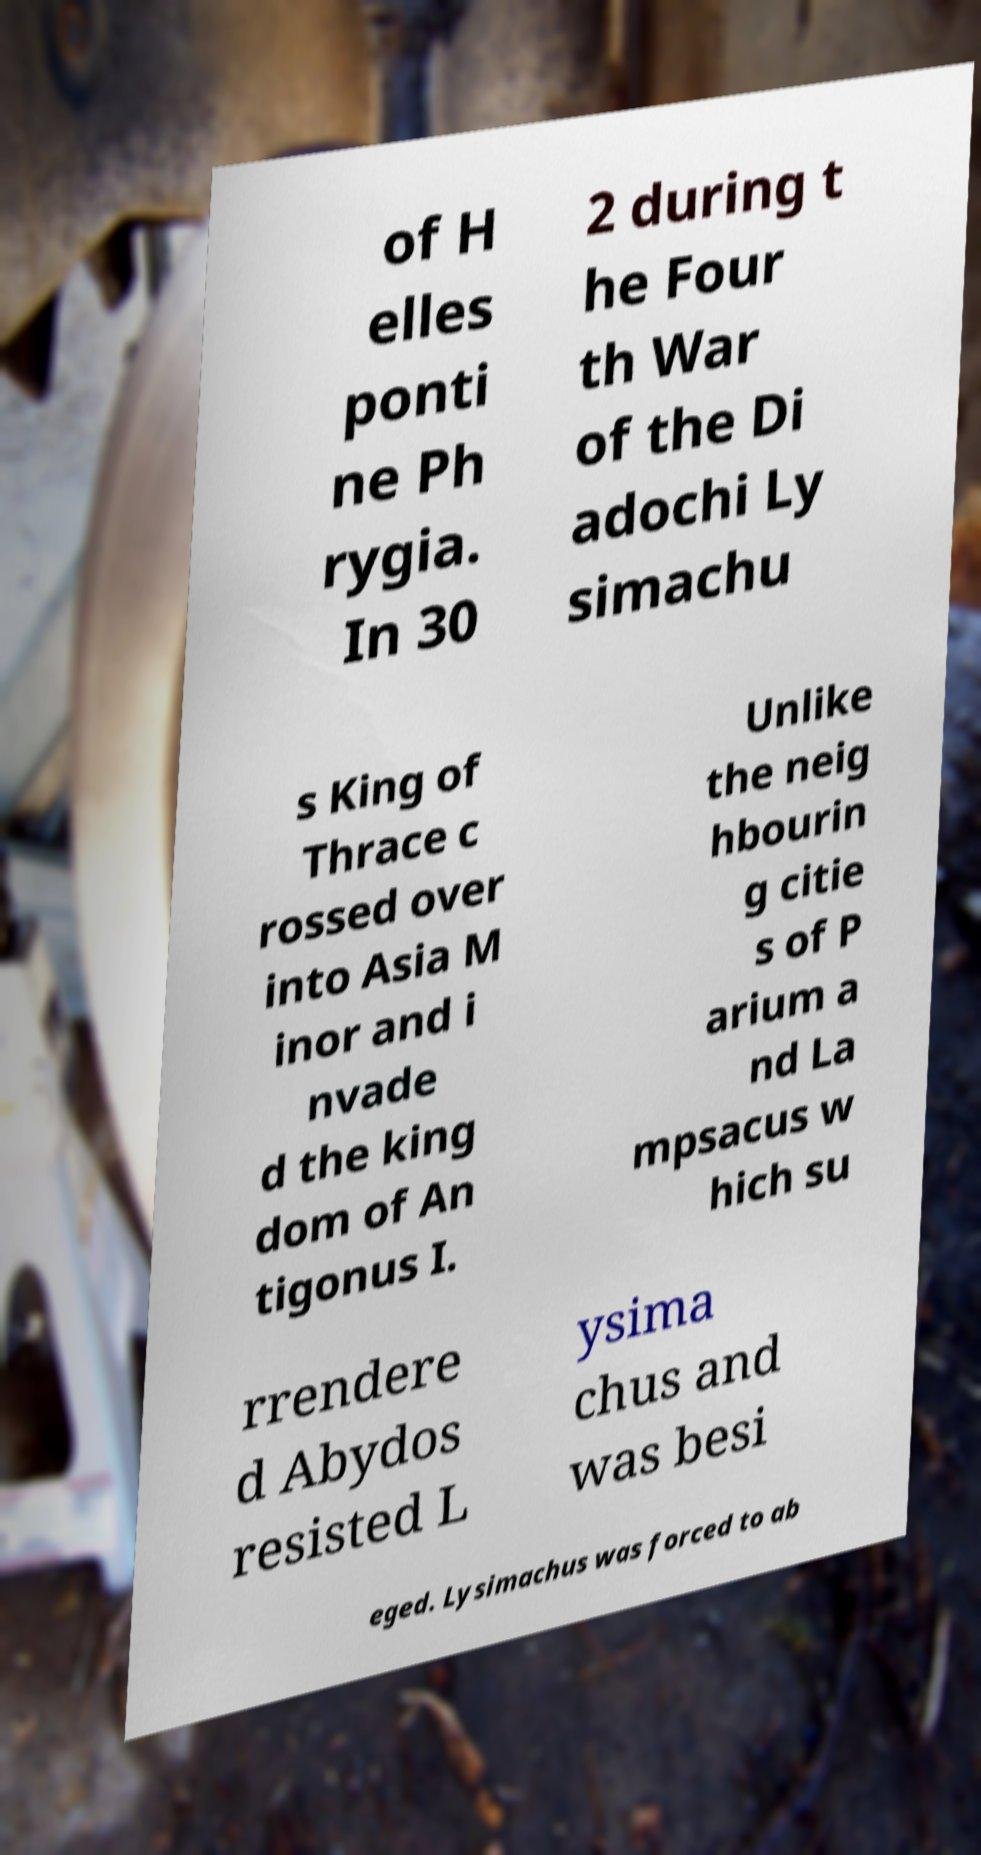Could you extract and type out the text from this image? of H elles ponti ne Ph rygia. In 30 2 during t he Four th War of the Di adochi Ly simachu s King of Thrace c rossed over into Asia M inor and i nvade d the king dom of An tigonus I. Unlike the neig hbourin g citie s of P arium a nd La mpsacus w hich su rrendere d Abydos resisted L ysima chus and was besi eged. Lysimachus was forced to ab 